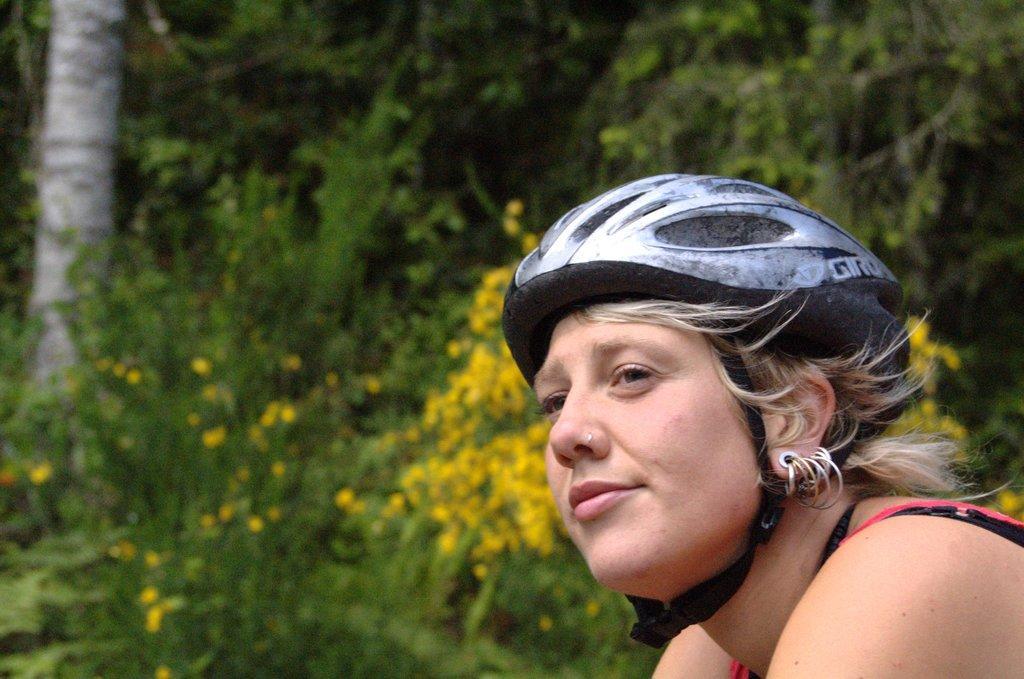In one or two sentences, can you explain what this image depicts? In the picture I can see a woman on the right side and there is a helmet on her head. I can see the trunk of a tree on the top left side of the picture. In the background, I can see the flowering plants and trees. 